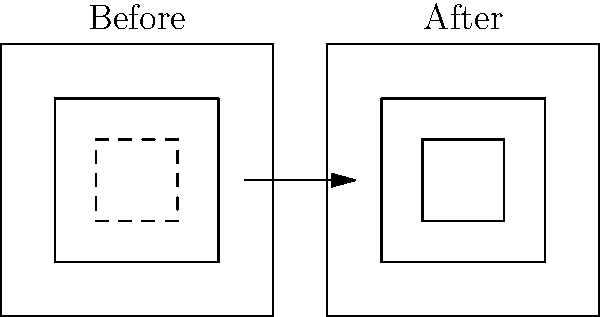In the reconstruction process of a degraded artifact found in a Mediterranean shipwreck, which technique is most likely used to fill in the missing or damaged areas, as illustrated in the "After" image? To answer this question, let's analyze the reconstruction process step-by-step:

1. The "Before" image shows a degraded artifact with a dashed line indicating missing or damaged areas.
2. The "After" image displays a reconstructed version of the artifact.
3. The missing areas in the "After" image have been filled in, creating a complete shape.
4. In marine archaeology, when reconstructing degraded artifacts, several techniques can be used:
   a) 3D scanning and modeling
   b) Photogrammetry
   c) Chemical analysis
   d) Comparative analysis with similar artifacts
5. However, the most common and effective technique for filling in missing areas is called "anastylosis."
6. Anastylosis involves using original fragments and complementing them with modern materials to recreate the artifact's original appearance.
7. This technique allows archaeologists to distinguish between original and reconstructed parts while providing a complete visual representation.
8. In the "After" image, we can see that the missing areas have been filled in, likely using modern materials that complement the original fragments.

Therefore, the most likely technique used to fill in the missing or damaged areas in this reconstruction process is anastylosis.
Answer: Anastylosis 